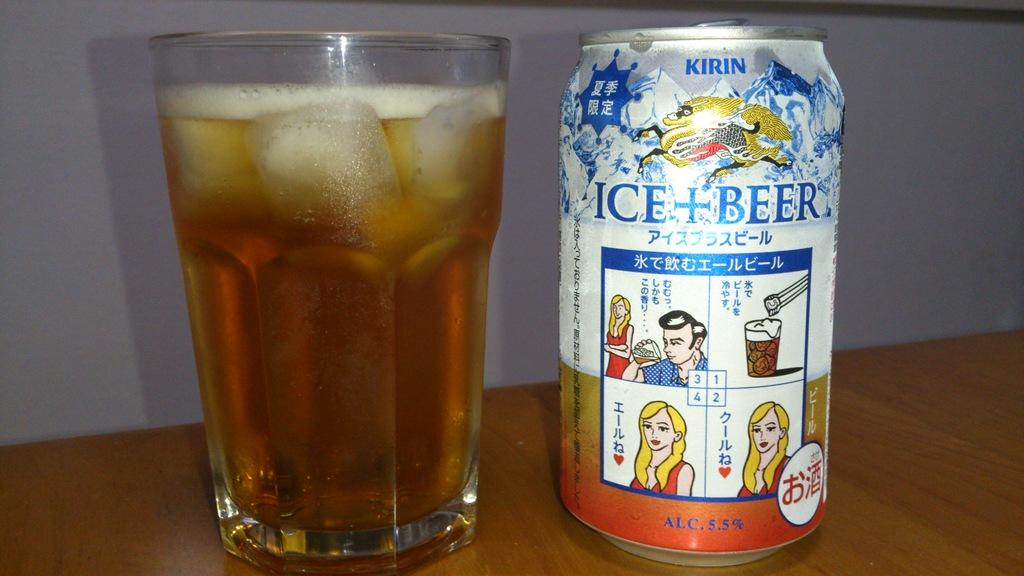<image>
Render a clear and concise summary of the photo. a beer that has the word ice on it with a cup next to it 